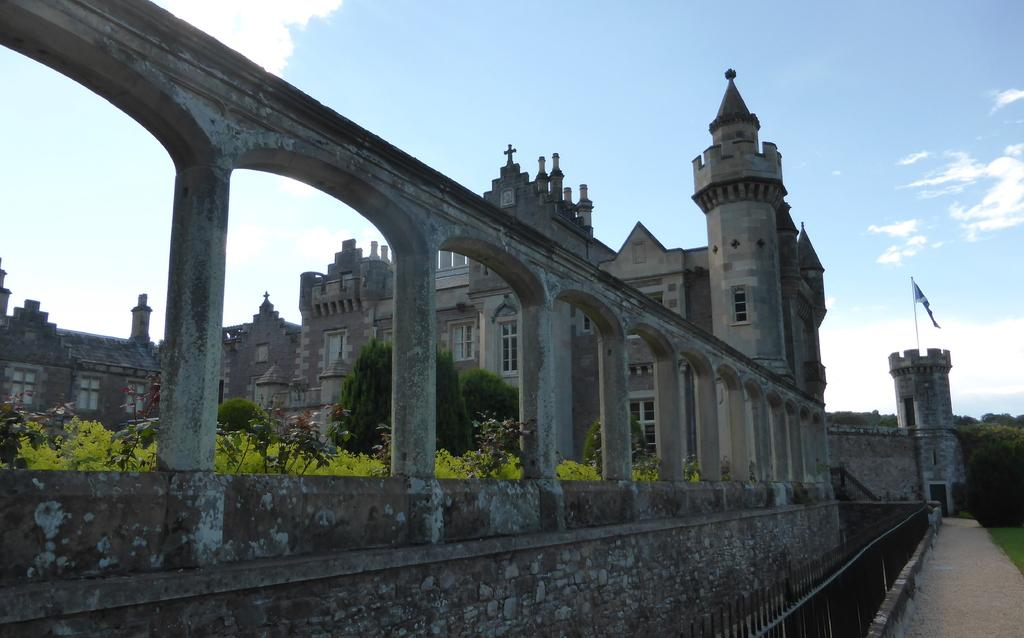What type of structures can be seen in the image? There are buildings in the image. What other natural elements are present in the image? There are plants and trees in the image. Can you describe the flag in the image? There is a flag on a building in the image. What type of fencing can be seen in the image? There are iron poles fencing in the image. How would you describe the weather in the image? The sky is cloudy in the image. Where is the button located in the image? There is no button present in the image. What type of ship can be seen sailing in the image? There is no ship present in the image. 